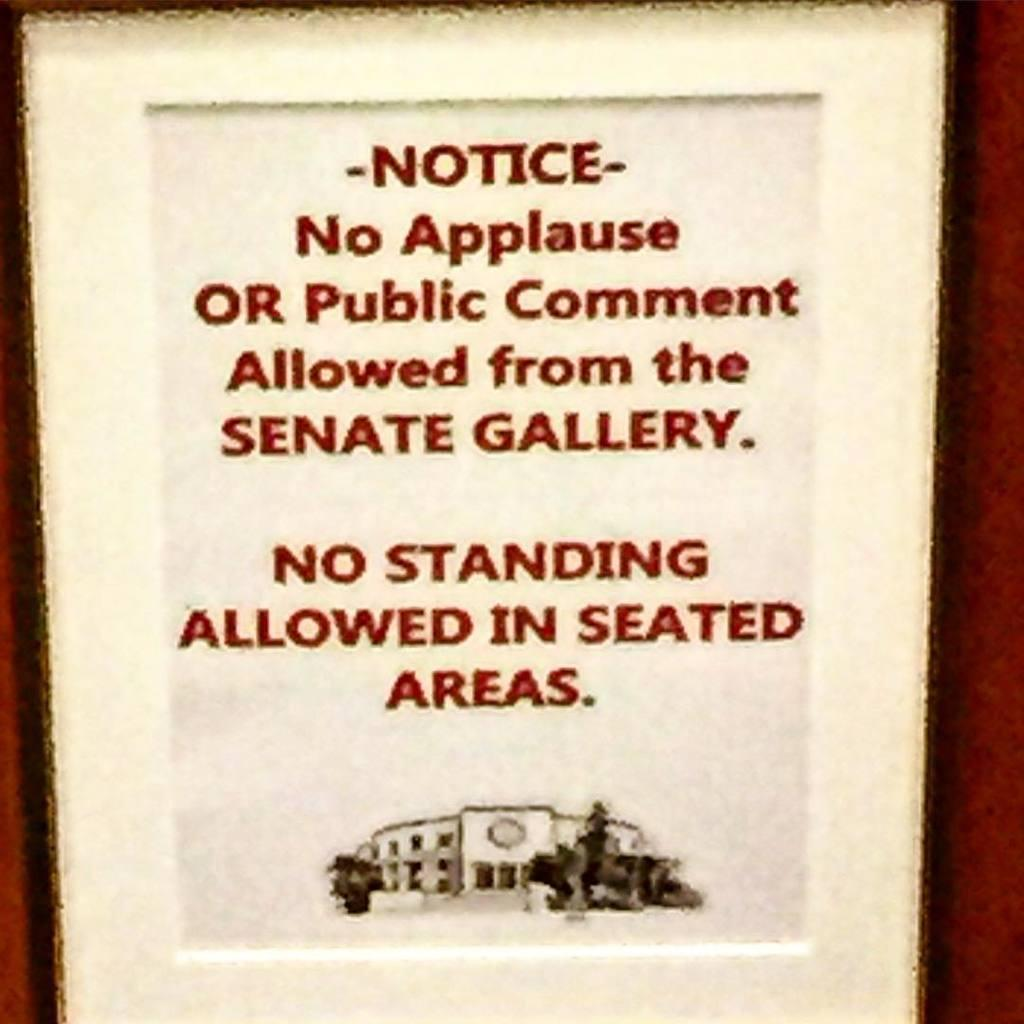<image>
Share a concise interpretation of the image provided. A Notice stating no applause or public comment allowed from the senate gallery. 